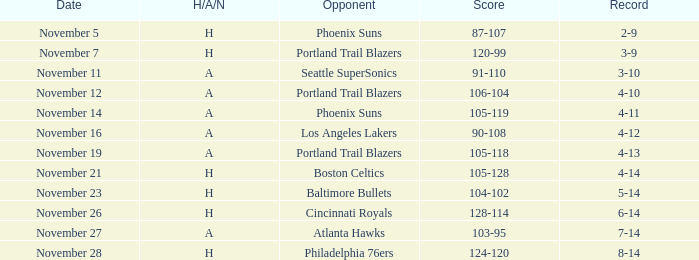On which date was the result 105-128? November 21. 